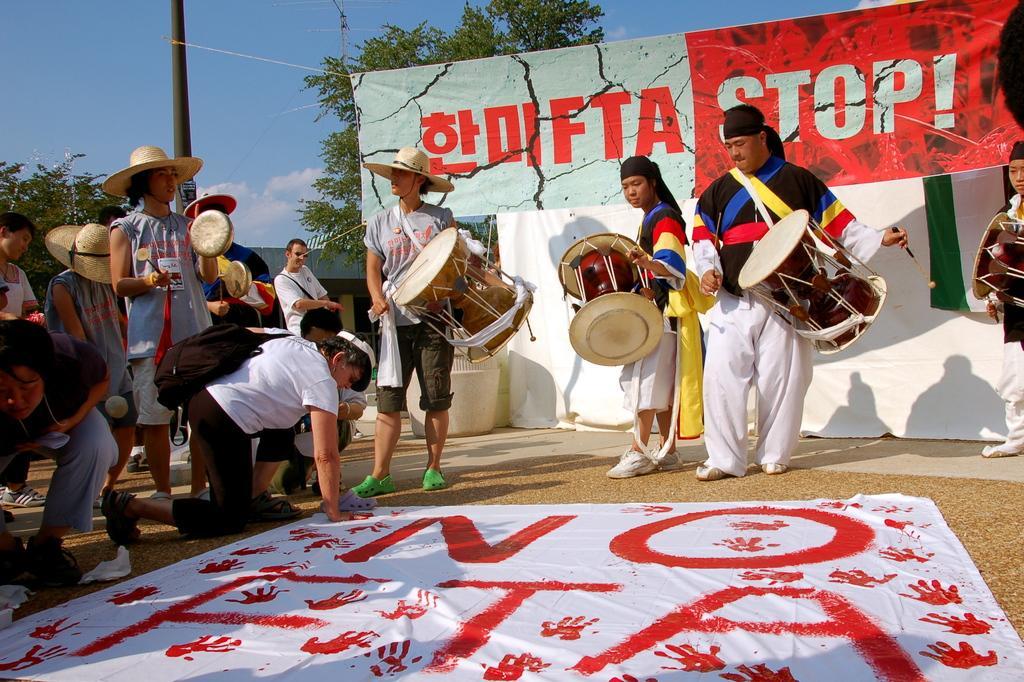How would you summarize this image in a sentence or two? In the left middle of the image, there are group of people performing culturistic dance. In the middle of the image, there are three person standing and playing drums. In the right middle of the image, there is one person standing and playing drums. In the background of the image, there is a sky blue in color and tree visible and a poster visible. And at the bottom of the image, there is a ground visible. This image is taken during day time. 